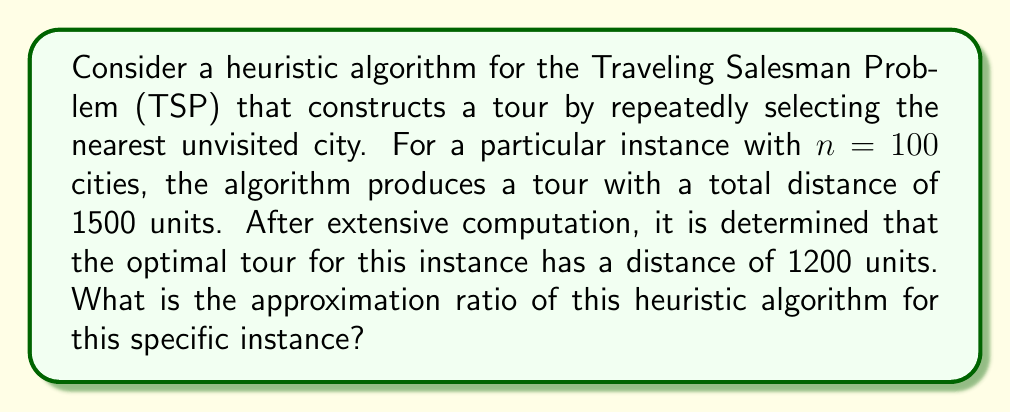Can you answer this question? To solve this problem, we need to understand the concept of approximation ratio and how it applies to heuristic algorithms for NP-hard optimization problems like the Traveling Salesman Problem (TSP).

1. The approximation ratio is defined as the ratio between the solution found by the heuristic algorithm and the optimal solution. It measures how close the heuristic solution is to the optimal solution.

2. For minimization problems like TSP, the approximation ratio is calculated as:

   $$ \text{Approximation Ratio} = \frac{\text{Heuristic Solution}}{\text{Optimal Solution}} $$

3. In this case, we have:
   - Heuristic solution (tour distance): 1500 units
   - Optimal solution (tour distance): 1200 units

4. Let's substitute these values into the formula:

   $$ \text{Approximation Ratio} = \frac{1500}{1200} $$

5. Simplify the fraction:

   $$ \text{Approximation Ratio} = \frac{5}{4} = 1.25 $$

This means that for this specific instance, the heuristic algorithm produces a solution that is 1.25 times the optimal solution.

It's important to note that this approximation ratio is for this specific instance only. In general, the nearest neighbor heuristic for TSP can perform much worse, with a worst-case approximation ratio of $O(\log n)$, where $n$ is the number of cities.
Answer: The approximation ratio of the heuristic algorithm for this specific instance is $\frac{5}{4}$ or 1.25. 